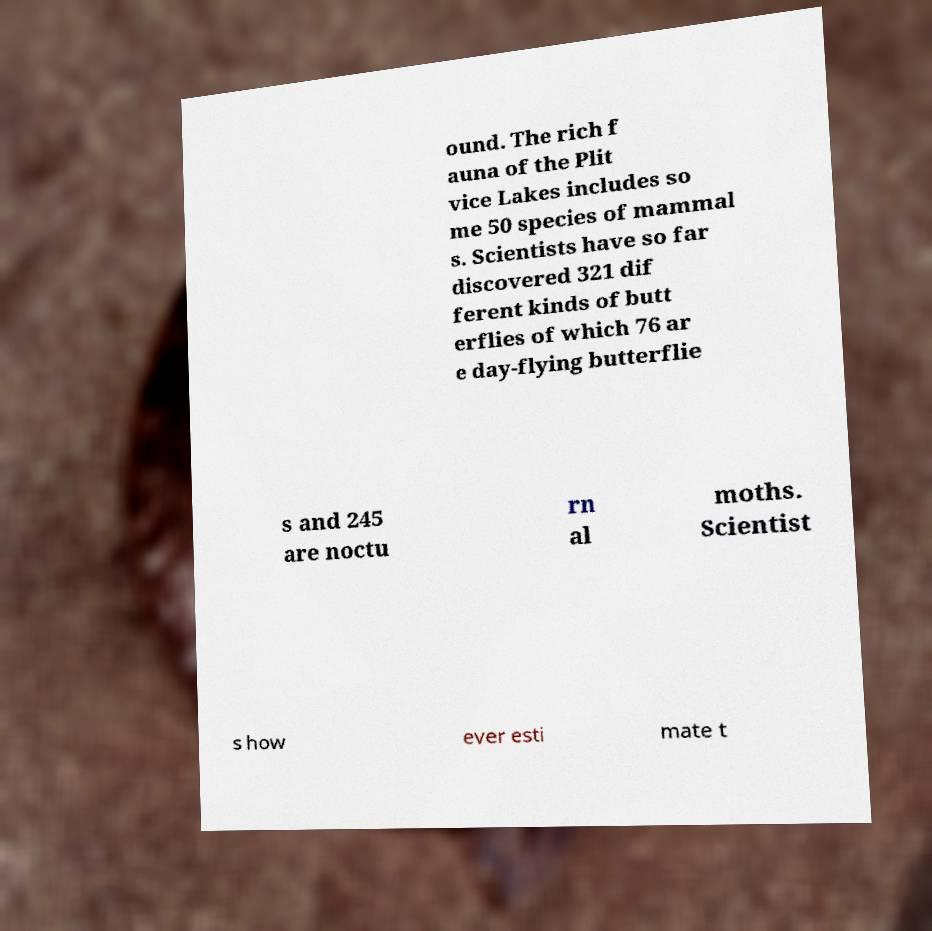Can you accurately transcribe the text from the provided image for me? ound. The rich f auna of the Plit vice Lakes includes so me 50 species of mammal s. Scientists have so far discovered 321 dif ferent kinds of butt erflies of which 76 ar e day-flying butterflie s and 245 are noctu rn al moths. Scientist s how ever esti mate t 